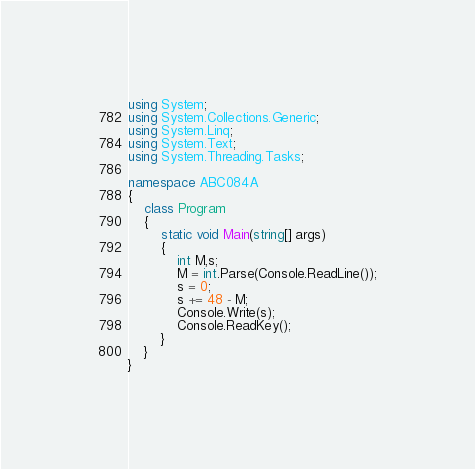<code> <loc_0><loc_0><loc_500><loc_500><_C#_>using System;
using System.Collections.Generic;
using System.Linq;
using System.Text;
using System.Threading.Tasks;

namespace ABC084A
{
    class Program
    {
        static void Main(string[] args)
        {
            int M,s;
            M = int.Parse(Console.ReadLine());
            s = 0;
            s += 48 - M;
            Console.Write(s);
            Console.ReadKey();
        }
    }
}
</code> 